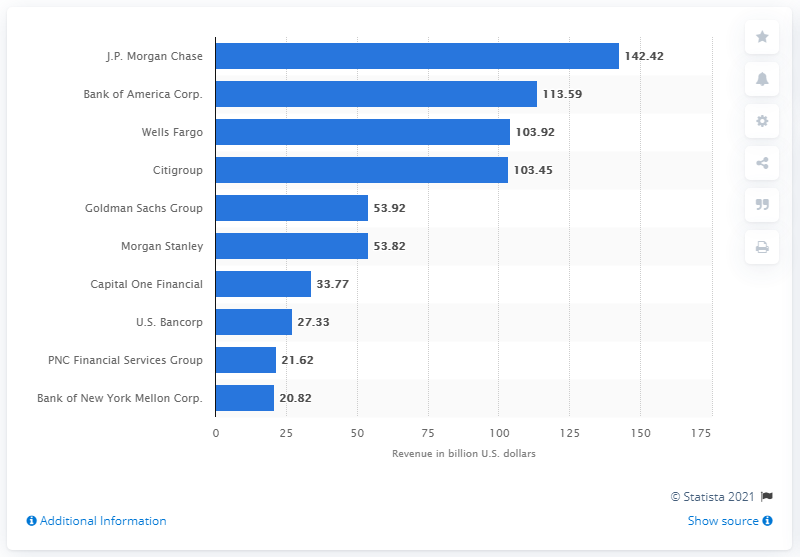Identify some key points in this picture. In 2019, J.P. Morgan Chase's total revenue was 142.42 dollars. 